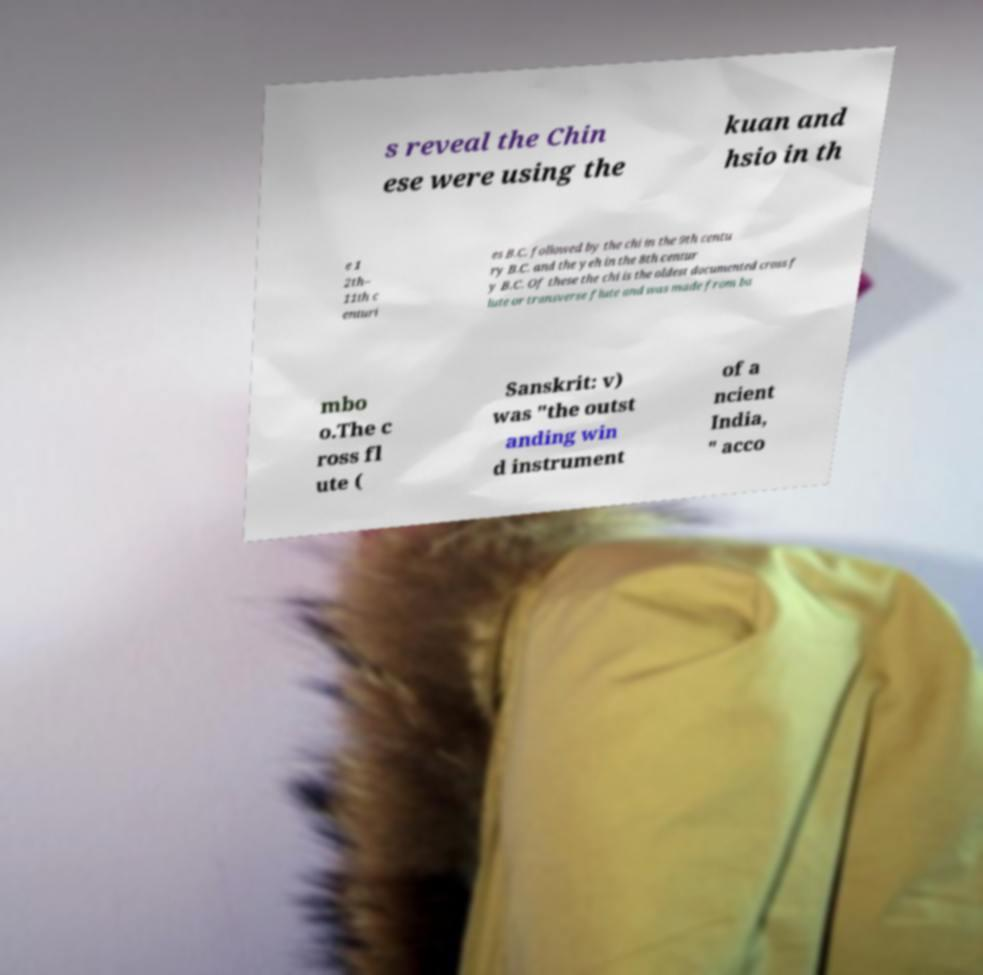I need the written content from this picture converted into text. Can you do that? s reveal the Chin ese were using the kuan and hsio in th e 1 2th– 11th c enturi es B.C. followed by the chi in the 9th centu ry B.C. and the yeh in the 8th centur y B.C. Of these the chi is the oldest documented cross f lute or transverse flute and was made from ba mbo o.The c ross fl ute ( Sanskrit: v) was "the outst anding win d instrument of a ncient India, " acco 